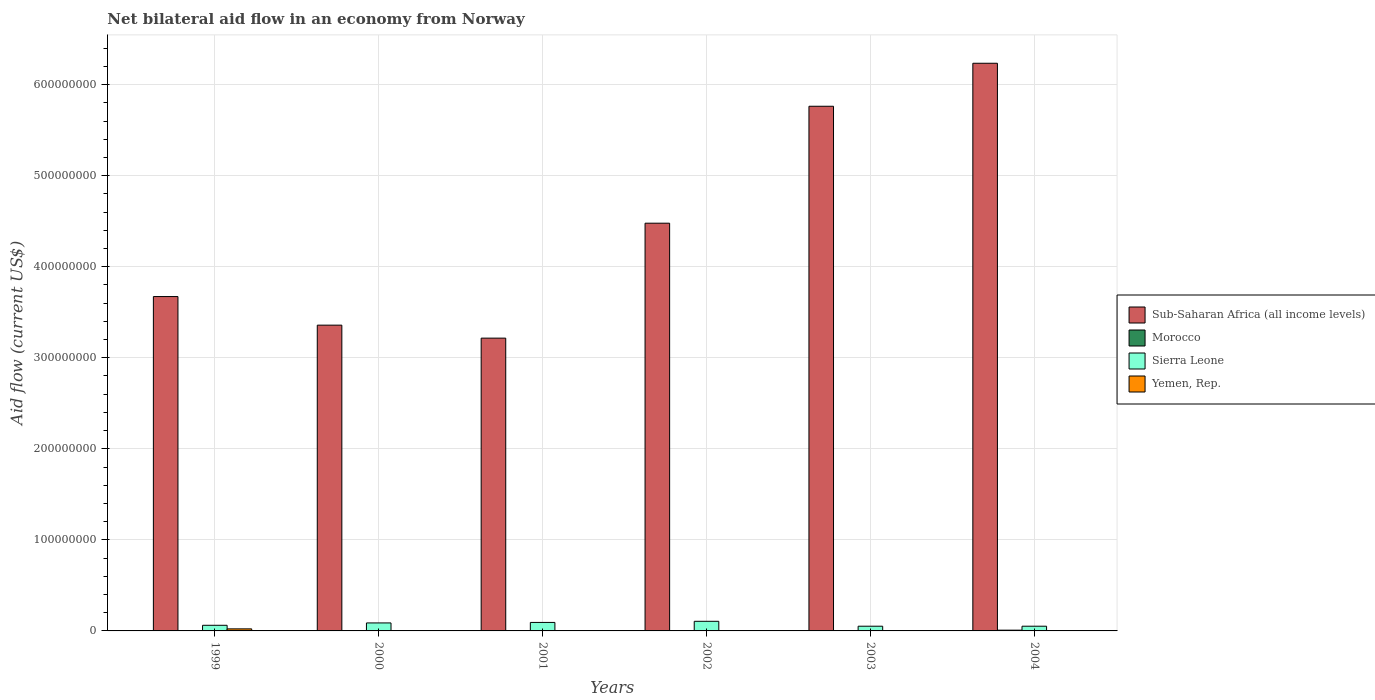How many different coloured bars are there?
Your response must be concise. 4. How many groups of bars are there?
Your answer should be very brief. 6. Are the number of bars on each tick of the X-axis equal?
Give a very brief answer. Yes. How many bars are there on the 1st tick from the left?
Provide a short and direct response. 4. How many bars are there on the 4th tick from the right?
Your answer should be compact. 4. What is the label of the 2nd group of bars from the left?
Provide a short and direct response. 2000. In how many cases, is the number of bars for a given year not equal to the number of legend labels?
Your answer should be very brief. 0. What is the net bilateral aid flow in Yemen, Rep. in 1999?
Ensure brevity in your answer.  2.25e+06. Across all years, what is the maximum net bilateral aid flow in Sub-Saharan Africa (all income levels)?
Provide a short and direct response. 6.23e+08. Across all years, what is the minimum net bilateral aid flow in Sierra Leone?
Make the answer very short. 5.17e+06. What is the total net bilateral aid flow in Sub-Saharan Africa (all income levels) in the graph?
Make the answer very short. 2.67e+09. What is the difference between the net bilateral aid flow in Sub-Saharan Africa (all income levels) in 1999 and that in 2002?
Your answer should be compact. -8.06e+07. What is the difference between the net bilateral aid flow in Morocco in 2001 and the net bilateral aid flow in Sierra Leone in 2004?
Make the answer very short. -5.08e+06. What is the average net bilateral aid flow in Sub-Saharan Africa (all income levels) per year?
Keep it short and to the point. 4.45e+08. In the year 2002, what is the difference between the net bilateral aid flow in Morocco and net bilateral aid flow in Sub-Saharan Africa (all income levels)?
Your answer should be compact. -4.48e+08. In how many years, is the net bilateral aid flow in Yemen, Rep. greater than 20000000 US$?
Offer a very short reply. 0. What is the ratio of the net bilateral aid flow in Morocco in 1999 to that in 2001?
Keep it short and to the point. 0.44. Is the net bilateral aid flow in Yemen, Rep. in 1999 less than that in 2000?
Offer a terse response. No. Is the difference between the net bilateral aid flow in Morocco in 2000 and 2002 greater than the difference between the net bilateral aid flow in Sub-Saharan Africa (all income levels) in 2000 and 2002?
Provide a succinct answer. Yes. What is the difference between the highest and the second highest net bilateral aid flow in Sierra Leone?
Offer a terse response. 1.24e+06. What is the difference between the highest and the lowest net bilateral aid flow in Yemen, Rep.?
Your answer should be very brief. 2.20e+06. Is the sum of the net bilateral aid flow in Yemen, Rep. in 2003 and 2004 greater than the maximum net bilateral aid flow in Sub-Saharan Africa (all income levels) across all years?
Provide a short and direct response. No. Is it the case that in every year, the sum of the net bilateral aid flow in Sierra Leone and net bilateral aid flow in Morocco is greater than the sum of net bilateral aid flow in Sub-Saharan Africa (all income levels) and net bilateral aid flow in Yemen, Rep.?
Your response must be concise. No. What does the 3rd bar from the left in 2001 represents?
Keep it short and to the point. Sierra Leone. What does the 1st bar from the right in 2004 represents?
Your answer should be very brief. Yemen, Rep. Are all the bars in the graph horizontal?
Offer a very short reply. No. How many years are there in the graph?
Provide a short and direct response. 6. Are the values on the major ticks of Y-axis written in scientific E-notation?
Make the answer very short. No. Does the graph contain any zero values?
Give a very brief answer. No. Does the graph contain grids?
Offer a terse response. Yes. What is the title of the graph?
Make the answer very short. Net bilateral aid flow in an economy from Norway. Does "Colombia" appear as one of the legend labels in the graph?
Keep it short and to the point. No. What is the label or title of the Y-axis?
Make the answer very short. Aid flow (current US$). What is the Aid flow (current US$) in Sub-Saharan Africa (all income levels) in 1999?
Your answer should be very brief. 3.67e+08. What is the Aid flow (current US$) of Sierra Leone in 1999?
Provide a short and direct response. 6.18e+06. What is the Aid flow (current US$) of Yemen, Rep. in 1999?
Your answer should be very brief. 2.25e+06. What is the Aid flow (current US$) in Sub-Saharan Africa (all income levels) in 2000?
Make the answer very short. 3.36e+08. What is the Aid flow (current US$) of Sierra Leone in 2000?
Make the answer very short. 8.77e+06. What is the Aid flow (current US$) in Sub-Saharan Africa (all income levels) in 2001?
Provide a short and direct response. 3.22e+08. What is the Aid flow (current US$) of Sierra Leone in 2001?
Provide a short and direct response. 9.33e+06. What is the Aid flow (current US$) of Sub-Saharan Africa (all income levels) in 2002?
Provide a succinct answer. 4.48e+08. What is the Aid flow (current US$) in Sierra Leone in 2002?
Your answer should be very brief. 1.06e+07. What is the Aid flow (current US$) of Yemen, Rep. in 2002?
Ensure brevity in your answer.  3.50e+05. What is the Aid flow (current US$) of Sub-Saharan Africa (all income levels) in 2003?
Your answer should be compact. 5.76e+08. What is the Aid flow (current US$) in Sierra Leone in 2003?
Offer a terse response. 5.18e+06. What is the Aid flow (current US$) of Yemen, Rep. in 2003?
Your answer should be very brief. 3.10e+05. What is the Aid flow (current US$) in Sub-Saharan Africa (all income levels) in 2004?
Give a very brief answer. 6.23e+08. What is the Aid flow (current US$) of Morocco in 2004?
Provide a succinct answer. 8.30e+05. What is the Aid flow (current US$) in Sierra Leone in 2004?
Provide a short and direct response. 5.17e+06. What is the Aid flow (current US$) in Yemen, Rep. in 2004?
Offer a very short reply. 4.30e+05. Across all years, what is the maximum Aid flow (current US$) in Sub-Saharan Africa (all income levels)?
Provide a short and direct response. 6.23e+08. Across all years, what is the maximum Aid flow (current US$) in Morocco?
Ensure brevity in your answer.  8.30e+05. Across all years, what is the maximum Aid flow (current US$) of Sierra Leone?
Your response must be concise. 1.06e+07. Across all years, what is the maximum Aid flow (current US$) of Yemen, Rep.?
Make the answer very short. 2.25e+06. Across all years, what is the minimum Aid flow (current US$) of Sub-Saharan Africa (all income levels)?
Provide a succinct answer. 3.22e+08. Across all years, what is the minimum Aid flow (current US$) of Morocco?
Your response must be concise. 4.00e+04. Across all years, what is the minimum Aid flow (current US$) in Sierra Leone?
Make the answer very short. 5.17e+06. Across all years, what is the minimum Aid flow (current US$) in Yemen, Rep.?
Provide a succinct answer. 5.00e+04. What is the total Aid flow (current US$) of Sub-Saharan Africa (all income levels) in the graph?
Offer a very short reply. 2.67e+09. What is the total Aid flow (current US$) in Morocco in the graph?
Give a very brief answer. 1.61e+06. What is the total Aid flow (current US$) in Sierra Leone in the graph?
Provide a short and direct response. 4.52e+07. What is the total Aid flow (current US$) of Yemen, Rep. in the graph?
Offer a terse response. 3.50e+06. What is the difference between the Aid flow (current US$) of Sub-Saharan Africa (all income levels) in 1999 and that in 2000?
Provide a short and direct response. 3.14e+07. What is the difference between the Aid flow (current US$) in Morocco in 1999 and that in 2000?
Provide a succinct answer. -8.00e+04. What is the difference between the Aid flow (current US$) in Sierra Leone in 1999 and that in 2000?
Make the answer very short. -2.59e+06. What is the difference between the Aid flow (current US$) of Yemen, Rep. in 1999 and that in 2000?
Your answer should be very brief. 2.14e+06. What is the difference between the Aid flow (current US$) of Sub-Saharan Africa (all income levels) in 1999 and that in 2001?
Provide a short and direct response. 4.57e+07. What is the difference between the Aid flow (current US$) in Morocco in 1999 and that in 2001?
Provide a short and direct response. -5.00e+04. What is the difference between the Aid flow (current US$) in Sierra Leone in 1999 and that in 2001?
Offer a terse response. -3.15e+06. What is the difference between the Aid flow (current US$) of Yemen, Rep. in 1999 and that in 2001?
Offer a terse response. 2.20e+06. What is the difference between the Aid flow (current US$) in Sub-Saharan Africa (all income levels) in 1999 and that in 2002?
Your answer should be very brief. -8.06e+07. What is the difference between the Aid flow (current US$) of Morocco in 1999 and that in 2002?
Your response must be concise. -1.30e+05. What is the difference between the Aid flow (current US$) in Sierra Leone in 1999 and that in 2002?
Ensure brevity in your answer.  -4.39e+06. What is the difference between the Aid flow (current US$) in Yemen, Rep. in 1999 and that in 2002?
Ensure brevity in your answer.  1.90e+06. What is the difference between the Aid flow (current US$) of Sub-Saharan Africa (all income levels) in 1999 and that in 2003?
Offer a terse response. -2.09e+08. What is the difference between the Aid flow (current US$) in Morocco in 1999 and that in 2003?
Your response must be concise. -3.20e+05. What is the difference between the Aid flow (current US$) in Sierra Leone in 1999 and that in 2003?
Offer a very short reply. 1.00e+06. What is the difference between the Aid flow (current US$) in Yemen, Rep. in 1999 and that in 2003?
Provide a succinct answer. 1.94e+06. What is the difference between the Aid flow (current US$) in Sub-Saharan Africa (all income levels) in 1999 and that in 2004?
Make the answer very short. -2.56e+08. What is the difference between the Aid flow (current US$) of Morocco in 1999 and that in 2004?
Keep it short and to the point. -7.90e+05. What is the difference between the Aid flow (current US$) in Sierra Leone in 1999 and that in 2004?
Provide a succinct answer. 1.01e+06. What is the difference between the Aid flow (current US$) in Yemen, Rep. in 1999 and that in 2004?
Provide a succinct answer. 1.82e+06. What is the difference between the Aid flow (current US$) of Sub-Saharan Africa (all income levels) in 2000 and that in 2001?
Ensure brevity in your answer.  1.43e+07. What is the difference between the Aid flow (current US$) of Sierra Leone in 2000 and that in 2001?
Offer a terse response. -5.60e+05. What is the difference between the Aid flow (current US$) of Sub-Saharan Africa (all income levels) in 2000 and that in 2002?
Offer a very short reply. -1.12e+08. What is the difference between the Aid flow (current US$) of Morocco in 2000 and that in 2002?
Offer a very short reply. -5.00e+04. What is the difference between the Aid flow (current US$) of Sierra Leone in 2000 and that in 2002?
Make the answer very short. -1.80e+06. What is the difference between the Aid flow (current US$) in Yemen, Rep. in 2000 and that in 2002?
Provide a succinct answer. -2.40e+05. What is the difference between the Aid flow (current US$) in Sub-Saharan Africa (all income levels) in 2000 and that in 2003?
Your response must be concise. -2.40e+08. What is the difference between the Aid flow (current US$) in Sierra Leone in 2000 and that in 2003?
Make the answer very short. 3.59e+06. What is the difference between the Aid flow (current US$) of Yemen, Rep. in 2000 and that in 2003?
Offer a very short reply. -2.00e+05. What is the difference between the Aid flow (current US$) of Sub-Saharan Africa (all income levels) in 2000 and that in 2004?
Offer a terse response. -2.88e+08. What is the difference between the Aid flow (current US$) of Morocco in 2000 and that in 2004?
Ensure brevity in your answer.  -7.10e+05. What is the difference between the Aid flow (current US$) in Sierra Leone in 2000 and that in 2004?
Offer a terse response. 3.60e+06. What is the difference between the Aid flow (current US$) of Yemen, Rep. in 2000 and that in 2004?
Your response must be concise. -3.20e+05. What is the difference between the Aid flow (current US$) in Sub-Saharan Africa (all income levels) in 2001 and that in 2002?
Your response must be concise. -1.26e+08. What is the difference between the Aid flow (current US$) of Morocco in 2001 and that in 2002?
Your answer should be very brief. -8.00e+04. What is the difference between the Aid flow (current US$) of Sierra Leone in 2001 and that in 2002?
Ensure brevity in your answer.  -1.24e+06. What is the difference between the Aid flow (current US$) in Yemen, Rep. in 2001 and that in 2002?
Your answer should be very brief. -3.00e+05. What is the difference between the Aid flow (current US$) of Sub-Saharan Africa (all income levels) in 2001 and that in 2003?
Provide a short and direct response. -2.55e+08. What is the difference between the Aid flow (current US$) in Morocco in 2001 and that in 2003?
Offer a terse response. -2.70e+05. What is the difference between the Aid flow (current US$) of Sierra Leone in 2001 and that in 2003?
Offer a very short reply. 4.15e+06. What is the difference between the Aid flow (current US$) in Sub-Saharan Africa (all income levels) in 2001 and that in 2004?
Keep it short and to the point. -3.02e+08. What is the difference between the Aid flow (current US$) of Morocco in 2001 and that in 2004?
Give a very brief answer. -7.40e+05. What is the difference between the Aid flow (current US$) of Sierra Leone in 2001 and that in 2004?
Your answer should be very brief. 4.16e+06. What is the difference between the Aid flow (current US$) of Yemen, Rep. in 2001 and that in 2004?
Make the answer very short. -3.80e+05. What is the difference between the Aid flow (current US$) in Sub-Saharan Africa (all income levels) in 2002 and that in 2003?
Your answer should be very brief. -1.28e+08. What is the difference between the Aid flow (current US$) in Morocco in 2002 and that in 2003?
Offer a terse response. -1.90e+05. What is the difference between the Aid flow (current US$) of Sierra Leone in 2002 and that in 2003?
Give a very brief answer. 5.39e+06. What is the difference between the Aid flow (current US$) of Yemen, Rep. in 2002 and that in 2003?
Provide a succinct answer. 4.00e+04. What is the difference between the Aid flow (current US$) of Sub-Saharan Africa (all income levels) in 2002 and that in 2004?
Keep it short and to the point. -1.76e+08. What is the difference between the Aid flow (current US$) in Morocco in 2002 and that in 2004?
Offer a terse response. -6.60e+05. What is the difference between the Aid flow (current US$) of Sierra Leone in 2002 and that in 2004?
Give a very brief answer. 5.40e+06. What is the difference between the Aid flow (current US$) in Yemen, Rep. in 2002 and that in 2004?
Offer a very short reply. -8.00e+04. What is the difference between the Aid flow (current US$) in Sub-Saharan Africa (all income levels) in 2003 and that in 2004?
Provide a succinct answer. -4.72e+07. What is the difference between the Aid flow (current US$) in Morocco in 2003 and that in 2004?
Provide a short and direct response. -4.70e+05. What is the difference between the Aid flow (current US$) of Yemen, Rep. in 2003 and that in 2004?
Offer a very short reply. -1.20e+05. What is the difference between the Aid flow (current US$) in Sub-Saharan Africa (all income levels) in 1999 and the Aid flow (current US$) in Morocco in 2000?
Offer a terse response. 3.67e+08. What is the difference between the Aid flow (current US$) in Sub-Saharan Africa (all income levels) in 1999 and the Aid flow (current US$) in Sierra Leone in 2000?
Provide a short and direct response. 3.58e+08. What is the difference between the Aid flow (current US$) in Sub-Saharan Africa (all income levels) in 1999 and the Aid flow (current US$) in Yemen, Rep. in 2000?
Provide a short and direct response. 3.67e+08. What is the difference between the Aid flow (current US$) in Morocco in 1999 and the Aid flow (current US$) in Sierra Leone in 2000?
Make the answer very short. -8.73e+06. What is the difference between the Aid flow (current US$) in Morocco in 1999 and the Aid flow (current US$) in Yemen, Rep. in 2000?
Offer a terse response. -7.00e+04. What is the difference between the Aid flow (current US$) of Sierra Leone in 1999 and the Aid flow (current US$) of Yemen, Rep. in 2000?
Make the answer very short. 6.07e+06. What is the difference between the Aid flow (current US$) in Sub-Saharan Africa (all income levels) in 1999 and the Aid flow (current US$) in Morocco in 2001?
Make the answer very short. 3.67e+08. What is the difference between the Aid flow (current US$) in Sub-Saharan Africa (all income levels) in 1999 and the Aid flow (current US$) in Sierra Leone in 2001?
Give a very brief answer. 3.58e+08. What is the difference between the Aid flow (current US$) in Sub-Saharan Africa (all income levels) in 1999 and the Aid flow (current US$) in Yemen, Rep. in 2001?
Provide a short and direct response. 3.67e+08. What is the difference between the Aid flow (current US$) of Morocco in 1999 and the Aid flow (current US$) of Sierra Leone in 2001?
Ensure brevity in your answer.  -9.29e+06. What is the difference between the Aid flow (current US$) of Morocco in 1999 and the Aid flow (current US$) of Yemen, Rep. in 2001?
Keep it short and to the point. -10000. What is the difference between the Aid flow (current US$) of Sierra Leone in 1999 and the Aid flow (current US$) of Yemen, Rep. in 2001?
Your answer should be very brief. 6.13e+06. What is the difference between the Aid flow (current US$) of Sub-Saharan Africa (all income levels) in 1999 and the Aid flow (current US$) of Morocco in 2002?
Provide a short and direct response. 3.67e+08. What is the difference between the Aid flow (current US$) of Sub-Saharan Africa (all income levels) in 1999 and the Aid flow (current US$) of Sierra Leone in 2002?
Keep it short and to the point. 3.57e+08. What is the difference between the Aid flow (current US$) of Sub-Saharan Africa (all income levels) in 1999 and the Aid flow (current US$) of Yemen, Rep. in 2002?
Keep it short and to the point. 3.67e+08. What is the difference between the Aid flow (current US$) of Morocco in 1999 and the Aid flow (current US$) of Sierra Leone in 2002?
Make the answer very short. -1.05e+07. What is the difference between the Aid flow (current US$) in Morocco in 1999 and the Aid flow (current US$) in Yemen, Rep. in 2002?
Your answer should be very brief. -3.10e+05. What is the difference between the Aid flow (current US$) of Sierra Leone in 1999 and the Aid flow (current US$) of Yemen, Rep. in 2002?
Your answer should be very brief. 5.83e+06. What is the difference between the Aid flow (current US$) in Sub-Saharan Africa (all income levels) in 1999 and the Aid flow (current US$) in Morocco in 2003?
Ensure brevity in your answer.  3.67e+08. What is the difference between the Aid flow (current US$) in Sub-Saharan Africa (all income levels) in 1999 and the Aid flow (current US$) in Sierra Leone in 2003?
Your answer should be very brief. 3.62e+08. What is the difference between the Aid flow (current US$) of Sub-Saharan Africa (all income levels) in 1999 and the Aid flow (current US$) of Yemen, Rep. in 2003?
Your answer should be very brief. 3.67e+08. What is the difference between the Aid flow (current US$) in Morocco in 1999 and the Aid flow (current US$) in Sierra Leone in 2003?
Your response must be concise. -5.14e+06. What is the difference between the Aid flow (current US$) in Sierra Leone in 1999 and the Aid flow (current US$) in Yemen, Rep. in 2003?
Provide a short and direct response. 5.87e+06. What is the difference between the Aid flow (current US$) in Sub-Saharan Africa (all income levels) in 1999 and the Aid flow (current US$) in Morocco in 2004?
Your response must be concise. 3.66e+08. What is the difference between the Aid flow (current US$) in Sub-Saharan Africa (all income levels) in 1999 and the Aid flow (current US$) in Sierra Leone in 2004?
Your answer should be compact. 3.62e+08. What is the difference between the Aid flow (current US$) of Sub-Saharan Africa (all income levels) in 1999 and the Aid flow (current US$) of Yemen, Rep. in 2004?
Ensure brevity in your answer.  3.67e+08. What is the difference between the Aid flow (current US$) of Morocco in 1999 and the Aid flow (current US$) of Sierra Leone in 2004?
Offer a terse response. -5.13e+06. What is the difference between the Aid flow (current US$) of Morocco in 1999 and the Aid flow (current US$) of Yemen, Rep. in 2004?
Provide a succinct answer. -3.90e+05. What is the difference between the Aid flow (current US$) in Sierra Leone in 1999 and the Aid flow (current US$) in Yemen, Rep. in 2004?
Provide a succinct answer. 5.75e+06. What is the difference between the Aid flow (current US$) in Sub-Saharan Africa (all income levels) in 2000 and the Aid flow (current US$) in Morocco in 2001?
Your response must be concise. 3.36e+08. What is the difference between the Aid flow (current US$) of Sub-Saharan Africa (all income levels) in 2000 and the Aid flow (current US$) of Sierra Leone in 2001?
Provide a succinct answer. 3.27e+08. What is the difference between the Aid flow (current US$) in Sub-Saharan Africa (all income levels) in 2000 and the Aid flow (current US$) in Yemen, Rep. in 2001?
Your answer should be compact. 3.36e+08. What is the difference between the Aid flow (current US$) of Morocco in 2000 and the Aid flow (current US$) of Sierra Leone in 2001?
Offer a terse response. -9.21e+06. What is the difference between the Aid flow (current US$) of Sierra Leone in 2000 and the Aid flow (current US$) of Yemen, Rep. in 2001?
Provide a succinct answer. 8.72e+06. What is the difference between the Aid flow (current US$) of Sub-Saharan Africa (all income levels) in 2000 and the Aid flow (current US$) of Morocco in 2002?
Provide a short and direct response. 3.36e+08. What is the difference between the Aid flow (current US$) in Sub-Saharan Africa (all income levels) in 2000 and the Aid flow (current US$) in Sierra Leone in 2002?
Ensure brevity in your answer.  3.25e+08. What is the difference between the Aid flow (current US$) of Sub-Saharan Africa (all income levels) in 2000 and the Aid flow (current US$) of Yemen, Rep. in 2002?
Provide a short and direct response. 3.35e+08. What is the difference between the Aid flow (current US$) of Morocco in 2000 and the Aid flow (current US$) of Sierra Leone in 2002?
Offer a very short reply. -1.04e+07. What is the difference between the Aid flow (current US$) of Sierra Leone in 2000 and the Aid flow (current US$) of Yemen, Rep. in 2002?
Make the answer very short. 8.42e+06. What is the difference between the Aid flow (current US$) in Sub-Saharan Africa (all income levels) in 2000 and the Aid flow (current US$) in Morocco in 2003?
Offer a very short reply. 3.35e+08. What is the difference between the Aid flow (current US$) of Sub-Saharan Africa (all income levels) in 2000 and the Aid flow (current US$) of Sierra Leone in 2003?
Ensure brevity in your answer.  3.31e+08. What is the difference between the Aid flow (current US$) in Sub-Saharan Africa (all income levels) in 2000 and the Aid flow (current US$) in Yemen, Rep. in 2003?
Ensure brevity in your answer.  3.36e+08. What is the difference between the Aid flow (current US$) of Morocco in 2000 and the Aid flow (current US$) of Sierra Leone in 2003?
Give a very brief answer. -5.06e+06. What is the difference between the Aid flow (current US$) of Morocco in 2000 and the Aid flow (current US$) of Yemen, Rep. in 2003?
Offer a very short reply. -1.90e+05. What is the difference between the Aid flow (current US$) of Sierra Leone in 2000 and the Aid flow (current US$) of Yemen, Rep. in 2003?
Keep it short and to the point. 8.46e+06. What is the difference between the Aid flow (current US$) of Sub-Saharan Africa (all income levels) in 2000 and the Aid flow (current US$) of Morocco in 2004?
Make the answer very short. 3.35e+08. What is the difference between the Aid flow (current US$) in Sub-Saharan Africa (all income levels) in 2000 and the Aid flow (current US$) in Sierra Leone in 2004?
Provide a succinct answer. 3.31e+08. What is the difference between the Aid flow (current US$) in Sub-Saharan Africa (all income levels) in 2000 and the Aid flow (current US$) in Yemen, Rep. in 2004?
Keep it short and to the point. 3.35e+08. What is the difference between the Aid flow (current US$) in Morocco in 2000 and the Aid flow (current US$) in Sierra Leone in 2004?
Your answer should be compact. -5.05e+06. What is the difference between the Aid flow (current US$) in Morocco in 2000 and the Aid flow (current US$) in Yemen, Rep. in 2004?
Your answer should be compact. -3.10e+05. What is the difference between the Aid flow (current US$) in Sierra Leone in 2000 and the Aid flow (current US$) in Yemen, Rep. in 2004?
Ensure brevity in your answer.  8.34e+06. What is the difference between the Aid flow (current US$) in Sub-Saharan Africa (all income levels) in 2001 and the Aid flow (current US$) in Morocco in 2002?
Your answer should be compact. 3.21e+08. What is the difference between the Aid flow (current US$) in Sub-Saharan Africa (all income levels) in 2001 and the Aid flow (current US$) in Sierra Leone in 2002?
Your response must be concise. 3.11e+08. What is the difference between the Aid flow (current US$) of Sub-Saharan Africa (all income levels) in 2001 and the Aid flow (current US$) of Yemen, Rep. in 2002?
Offer a terse response. 3.21e+08. What is the difference between the Aid flow (current US$) of Morocco in 2001 and the Aid flow (current US$) of Sierra Leone in 2002?
Your response must be concise. -1.05e+07. What is the difference between the Aid flow (current US$) of Morocco in 2001 and the Aid flow (current US$) of Yemen, Rep. in 2002?
Your answer should be very brief. -2.60e+05. What is the difference between the Aid flow (current US$) in Sierra Leone in 2001 and the Aid flow (current US$) in Yemen, Rep. in 2002?
Provide a short and direct response. 8.98e+06. What is the difference between the Aid flow (current US$) of Sub-Saharan Africa (all income levels) in 2001 and the Aid flow (current US$) of Morocco in 2003?
Give a very brief answer. 3.21e+08. What is the difference between the Aid flow (current US$) of Sub-Saharan Africa (all income levels) in 2001 and the Aid flow (current US$) of Sierra Leone in 2003?
Offer a very short reply. 3.16e+08. What is the difference between the Aid flow (current US$) of Sub-Saharan Africa (all income levels) in 2001 and the Aid flow (current US$) of Yemen, Rep. in 2003?
Give a very brief answer. 3.21e+08. What is the difference between the Aid flow (current US$) in Morocco in 2001 and the Aid flow (current US$) in Sierra Leone in 2003?
Your response must be concise. -5.09e+06. What is the difference between the Aid flow (current US$) in Morocco in 2001 and the Aid flow (current US$) in Yemen, Rep. in 2003?
Offer a terse response. -2.20e+05. What is the difference between the Aid flow (current US$) in Sierra Leone in 2001 and the Aid flow (current US$) in Yemen, Rep. in 2003?
Keep it short and to the point. 9.02e+06. What is the difference between the Aid flow (current US$) in Sub-Saharan Africa (all income levels) in 2001 and the Aid flow (current US$) in Morocco in 2004?
Your answer should be very brief. 3.21e+08. What is the difference between the Aid flow (current US$) in Sub-Saharan Africa (all income levels) in 2001 and the Aid flow (current US$) in Sierra Leone in 2004?
Your answer should be very brief. 3.16e+08. What is the difference between the Aid flow (current US$) of Sub-Saharan Africa (all income levels) in 2001 and the Aid flow (current US$) of Yemen, Rep. in 2004?
Your response must be concise. 3.21e+08. What is the difference between the Aid flow (current US$) of Morocco in 2001 and the Aid flow (current US$) of Sierra Leone in 2004?
Provide a succinct answer. -5.08e+06. What is the difference between the Aid flow (current US$) in Sierra Leone in 2001 and the Aid flow (current US$) in Yemen, Rep. in 2004?
Give a very brief answer. 8.90e+06. What is the difference between the Aid flow (current US$) in Sub-Saharan Africa (all income levels) in 2002 and the Aid flow (current US$) in Morocco in 2003?
Offer a very short reply. 4.47e+08. What is the difference between the Aid flow (current US$) of Sub-Saharan Africa (all income levels) in 2002 and the Aid flow (current US$) of Sierra Leone in 2003?
Offer a terse response. 4.43e+08. What is the difference between the Aid flow (current US$) in Sub-Saharan Africa (all income levels) in 2002 and the Aid flow (current US$) in Yemen, Rep. in 2003?
Your answer should be compact. 4.48e+08. What is the difference between the Aid flow (current US$) in Morocco in 2002 and the Aid flow (current US$) in Sierra Leone in 2003?
Offer a terse response. -5.01e+06. What is the difference between the Aid flow (current US$) of Sierra Leone in 2002 and the Aid flow (current US$) of Yemen, Rep. in 2003?
Give a very brief answer. 1.03e+07. What is the difference between the Aid flow (current US$) of Sub-Saharan Africa (all income levels) in 2002 and the Aid flow (current US$) of Morocco in 2004?
Provide a succinct answer. 4.47e+08. What is the difference between the Aid flow (current US$) of Sub-Saharan Africa (all income levels) in 2002 and the Aid flow (current US$) of Sierra Leone in 2004?
Your response must be concise. 4.43e+08. What is the difference between the Aid flow (current US$) of Sub-Saharan Africa (all income levels) in 2002 and the Aid flow (current US$) of Yemen, Rep. in 2004?
Offer a very short reply. 4.47e+08. What is the difference between the Aid flow (current US$) of Morocco in 2002 and the Aid flow (current US$) of Sierra Leone in 2004?
Keep it short and to the point. -5.00e+06. What is the difference between the Aid flow (current US$) in Sierra Leone in 2002 and the Aid flow (current US$) in Yemen, Rep. in 2004?
Offer a very short reply. 1.01e+07. What is the difference between the Aid flow (current US$) of Sub-Saharan Africa (all income levels) in 2003 and the Aid flow (current US$) of Morocco in 2004?
Offer a terse response. 5.75e+08. What is the difference between the Aid flow (current US$) of Sub-Saharan Africa (all income levels) in 2003 and the Aid flow (current US$) of Sierra Leone in 2004?
Provide a short and direct response. 5.71e+08. What is the difference between the Aid flow (current US$) in Sub-Saharan Africa (all income levels) in 2003 and the Aid flow (current US$) in Yemen, Rep. in 2004?
Provide a succinct answer. 5.76e+08. What is the difference between the Aid flow (current US$) in Morocco in 2003 and the Aid flow (current US$) in Sierra Leone in 2004?
Make the answer very short. -4.81e+06. What is the difference between the Aid flow (current US$) of Morocco in 2003 and the Aid flow (current US$) of Yemen, Rep. in 2004?
Offer a terse response. -7.00e+04. What is the difference between the Aid flow (current US$) in Sierra Leone in 2003 and the Aid flow (current US$) in Yemen, Rep. in 2004?
Your response must be concise. 4.75e+06. What is the average Aid flow (current US$) in Sub-Saharan Africa (all income levels) per year?
Provide a succinct answer. 4.45e+08. What is the average Aid flow (current US$) in Morocco per year?
Make the answer very short. 2.68e+05. What is the average Aid flow (current US$) of Sierra Leone per year?
Ensure brevity in your answer.  7.53e+06. What is the average Aid flow (current US$) in Yemen, Rep. per year?
Provide a short and direct response. 5.83e+05. In the year 1999, what is the difference between the Aid flow (current US$) of Sub-Saharan Africa (all income levels) and Aid flow (current US$) of Morocco?
Offer a terse response. 3.67e+08. In the year 1999, what is the difference between the Aid flow (current US$) in Sub-Saharan Africa (all income levels) and Aid flow (current US$) in Sierra Leone?
Give a very brief answer. 3.61e+08. In the year 1999, what is the difference between the Aid flow (current US$) of Sub-Saharan Africa (all income levels) and Aid flow (current US$) of Yemen, Rep.?
Ensure brevity in your answer.  3.65e+08. In the year 1999, what is the difference between the Aid flow (current US$) in Morocco and Aid flow (current US$) in Sierra Leone?
Offer a terse response. -6.14e+06. In the year 1999, what is the difference between the Aid flow (current US$) in Morocco and Aid flow (current US$) in Yemen, Rep.?
Provide a short and direct response. -2.21e+06. In the year 1999, what is the difference between the Aid flow (current US$) of Sierra Leone and Aid flow (current US$) of Yemen, Rep.?
Your response must be concise. 3.93e+06. In the year 2000, what is the difference between the Aid flow (current US$) in Sub-Saharan Africa (all income levels) and Aid flow (current US$) in Morocco?
Keep it short and to the point. 3.36e+08. In the year 2000, what is the difference between the Aid flow (current US$) of Sub-Saharan Africa (all income levels) and Aid flow (current US$) of Sierra Leone?
Provide a short and direct response. 3.27e+08. In the year 2000, what is the difference between the Aid flow (current US$) in Sub-Saharan Africa (all income levels) and Aid flow (current US$) in Yemen, Rep.?
Offer a terse response. 3.36e+08. In the year 2000, what is the difference between the Aid flow (current US$) of Morocco and Aid flow (current US$) of Sierra Leone?
Provide a succinct answer. -8.65e+06. In the year 2000, what is the difference between the Aid flow (current US$) of Sierra Leone and Aid flow (current US$) of Yemen, Rep.?
Keep it short and to the point. 8.66e+06. In the year 2001, what is the difference between the Aid flow (current US$) of Sub-Saharan Africa (all income levels) and Aid flow (current US$) of Morocco?
Keep it short and to the point. 3.21e+08. In the year 2001, what is the difference between the Aid flow (current US$) in Sub-Saharan Africa (all income levels) and Aid flow (current US$) in Sierra Leone?
Give a very brief answer. 3.12e+08. In the year 2001, what is the difference between the Aid flow (current US$) of Sub-Saharan Africa (all income levels) and Aid flow (current US$) of Yemen, Rep.?
Provide a short and direct response. 3.22e+08. In the year 2001, what is the difference between the Aid flow (current US$) of Morocco and Aid flow (current US$) of Sierra Leone?
Offer a terse response. -9.24e+06. In the year 2001, what is the difference between the Aid flow (current US$) of Sierra Leone and Aid flow (current US$) of Yemen, Rep.?
Your answer should be compact. 9.28e+06. In the year 2002, what is the difference between the Aid flow (current US$) of Sub-Saharan Africa (all income levels) and Aid flow (current US$) of Morocco?
Offer a very short reply. 4.48e+08. In the year 2002, what is the difference between the Aid flow (current US$) in Sub-Saharan Africa (all income levels) and Aid flow (current US$) in Sierra Leone?
Your answer should be compact. 4.37e+08. In the year 2002, what is the difference between the Aid flow (current US$) in Sub-Saharan Africa (all income levels) and Aid flow (current US$) in Yemen, Rep.?
Provide a short and direct response. 4.47e+08. In the year 2002, what is the difference between the Aid flow (current US$) of Morocco and Aid flow (current US$) of Sierra Leone?
Your answer should be compact. -1.04e+07. In the year 2002, what is the difference between the Aid flow (current US$) in Sierra Leone and Aid flow (current US$) in Yemen, Rep.?
Your response must be concise. 1.02e+07. In the year 2003, what is the difference between the Aid flow (current US$) of Sub-Saharan Africa (all income levels) and Aid flow (current US$) of Morocco?
Make the answer very short. 5.76e+08. In the year 2003, what is the difference between the Aid flow (current US$) in Sub-Saharan Africa (all income levels) and Aid flow (current US$) in Sierra Leone?
Give a very brief answer. 5.71e+08. In the year 2003, what is the difference between the Aid flow (current US$) of Sub-Saharan Africa (all income levels) and Aid flow (current US$) of Yemen, Rep.?
Provide a succinct answer. 5.76e+08. In the year 2003, what is the difference between the Aid flow (current US$) in Morocco and Aid flow (current US$) in Sierra Leone?
Make the answer very short. -4.82e+06. In the year 2003, what is the difference between the Aid flow (current US$) of Sierra Leone and Aid flow (current US$) of Yemen, Rep.?
Offer a terse response. 4.87e+06. In the year 2004, what is the difference between the Aid flow (current US$) of Sub-Saharan Africa (all income levels) and Aid flow (current US$) of Morocco?
Ensure brevity in your answer.  6.23e+08. In the year 2004, what is the difference between the Aid flow (current US$) of Sub-Saharan Africa (all income levels) and Aid flow (current US$) of Sierra Leone?
Your response must be concise. 6.18e+08. In the year 2004, what is the difference between the Aid flow (current US$) of Sub-Saharan Africa (all income levels) and Aid flow (current US$) of Yemen, Rep.?
Your answer should be compact. 6.23e+08. In the year 2004, what is the difference between the Aid flow (current US$) in Morocco and Aid flow (current US$) in Sierra Leone?
Offer a very short reply. -4.34e+06. In the year 2004, what is the difference between the Aid flow (current US$) of Sierra Leone and Aid flow (current US$) of Yemen, Rep.?
Provide a short and direct response. 4.74e+06. What is the ratio of the Aid flow (current US$) in Sub-Saharan Africa (all income levels) in 1999 to that in 2000?
Keep it short and to the point. 1.09. What is the ratio of the Aid flow (current US$) in Morocco in 1999 to that in 2000?
Ensure brevity in your answer.  0.33. What is the ratio of the Aid flow (current US$) of Sierra Leone in 1999 to that in 2000?
Your response must be concise. 0.7. What is the ratio of the Aid flow (current US$) of Yemen, Rep. in 1999 to that in 2000?
Your answer should be very brief. 20.45. What is the ratio of the Aid flow (current US$) of Sub-Saharan Africa (all income levels) in 1999 to that in 2001?
Offer a terse response. 1.14. What is the ratio of the Aid flow (current US$) in Morocco in 1999 to that in 2001?
Offer a very short reply. 0.44. What is the ratio of the Aid flow (current US$) of Sierra Leone in 1999 to that in 2001?
Your answer should be compact. 0.66. What is the ratio of the Aid flow (current US$) of Yemen, Rep. in 1999 to that in 2001?
Ensure brevity in your answer.  45. What is the ratio of the Aid flow (current US$) of Sub-Saharan Africa (all income levels) in 1999 to that in 2002?
Provide a succinct answer. 0.82. What is the ratio of the Aid flow (current US$) in Morocco in 1999 to that in 2002?
Give a very brief answer. 0.24. What is the ratio of the Aid flow (current US$) in Sierra Leone in 1999 to that in 2002?
Your answer should be compact. 0.58. What is the ratio of the Aid flow (current US$) in Yemen, Rep. in 1999 to that in 2002?
Offer a terse response. 6.43. What is the ratio of the Aid flow (current US$) in Sub-Saharan Africa (all income levels) in 1999 to that in 2003?
Your answer should be very brief. 0.64. What is the ratio of the Aid flow (current US$) in Sierra Leone in 1999 to that in 2003?
Ensure brevity in your answer.  1.19. What is the ratio of the Aid flow (current US$) of Yemen, Rep. in 1999 to that in 2003?
Your answer should be very brief. 7.26. What is the ratio of the Aid flow (current US$) in Sub-Saharan Africa (all income levels) in 1999 to that in 2004?
Your answer should be very brief. 0.59. What is the ratio of the Aid flow (current US$) of Morocco in 1999 to that in 2004?
Provide a short and direct response. 0.05. What is the ratio of the Aid flow (current US$) of Sierra Leone in 1999 to that in 2004?
Offer a very short reply. 1.2. What is the ratio of the Aid flow (current US$) in Yemen, Rep. in 1999 to that in 2004?
Your answer should be compact. 5.23. What is the ratio of the Aid flow (current US$) in Sub-Saharan Africa (all income levels) in 2000 to that in 2001?
Offer a terse response. 1.04. What is the ratio of the Aid flow (current US$) of Morocco in 2000 to that in 2001?
Your answer should be very brief. 1.33. What is the ratio of the Aid flow (current US$) in Sierra Leone in 2000 to that in 2001?
Your answer should be very brief. 0.94. What is the ratio of the Aid flow (current US$) in Sub-Saharan Africa (all income levels) in 2000 to that in 2002?
Make the answer very short. 0.75. What is the ratio of the Aid flow (current US$) of Morocco in 2000 to that in 2002?
Your answer should be compact. 0.71. What is the ratio of the Aid flow (current US$) in Sierra Leone in 2000 to that in 2002?
Your answer should be very brief. 0.83. What is the ratio of the Aid flow (current US$) in Yemen, Rep. in 2000 to that in 2002?
Keep it short and to the point. 0.31. What is the ratio of the Aid flow (current US$) of Sub-Saharan Africa (all income levels) in 2000 to that in 2003?
Give a very brief answer. 0.58. What is the ratio of the Aid flow (current US$) of Morocco in 2000 to that in 2003?
Provide a succinct answer. 0.33. What is the ratio of the Aid flow (current US$) of Sierra Leone in 2000 to that in 2003?
Ensure brevity in your answer.  1.69. What is the ratio of the Aid flow (current US$) in Yemen, Rep. in 2000 to that in 2003?
Offer a terse response. 0.35. What is the ratio of the Aid flow (current US$) in Sub-Saharan Africa (all income levels) in 2000 to that in 2004?
Ensure brevity in your answer.  0.54. What is the ratio of the Aid flow (current US$) of Morocco in 2000 to that in 2004?
Ensure brevity in your answer.  0.14. What is the ratio of the Aid flow (current US$) in Sierra Leone in 2000 to that in 2004?
Keep it short and to the point. 1.7. What is the ratio of the Aid flow (current US$) of Yemen, Rep. in 2000 to that in 2004?
Make the answer very short. 0.26. What is the ratio of the Aid flow (current US$) of Sub-Saharan Africa (all income levels) in 2001 to that in 2002?
Your answer should be compact. 0.72. What is the ratio of the Aid flow (current US$) in Morocco in 2001 to that in 2002?
Offer a very short reply. 0.53. What is the ratio of the Aid flow (current US$) in Sierra Leone in 2001 to that in 2002?
Your answer should be compact. 0.88. What is the ratio of the Aid flow (current US$) in Yemen, Rep. in 2001 to that in 2002?
Your answer should be compact. 0.14. What is the ratio of the Aid flow (current US$) in Sub-Saharan Africa (all income levels) in 2001 to that in 2003?
Your answer should be compact. 0.56. What is the ratio of the Aid flow (current US$) in Morocco in 2001 to that in 2003?
Offer a terse response. 0.25. What is the ratio of the Aid flow (current US$) of Sierra Leone in 2001 to that in 2003?
Give a very brief answer. 1.8. What is the ratio of the Aid flow (current US$) in Yemen, Rep. in 2001 to that in 2003?
Your answer should be compact. 0.16. What is the ratio of the Aid flow (current US$) of Sub-Saharan Africa (all income levels) in 2001 to that in 2004?
Ensure brevity in your answer.  0.52. What is the ratio of the Aid flow (current US$) in Morocco in 2001 to that in 2004?
Keep it short and to the point. 0.11. What is the ratio of the Aid flow (current US$) in Sierra Leone in 2001 to that in 2004?
Provide a succinct answer. 1.8. What is the ratio of the Aid flow (current US$) of Yemen, Rep. in 2001 to that in 2004?
Give a very brief answer. 0.12. What is the ratio of the Aid flow (current US$) in Sub-Saharan Africa (all income levels) in 2002 to that in 2003?
Your answer should be very brief. 0.78. What is the ratio of the Aid flow (current US$) in Morocco in 2002 to that in 2003?
Your answer should be compact. 0.47. What is the ratio of the Aid flow (current US$) in Sierra Leone in 2002 to that in 2003?
Offer a terse response. 2.04. What is the ratio of the Aid flow (current US$) in Yemen, Rep. in 2002 to that in 2003?
Your answer should be compact. 1.13. What is the ratio of the Aid flow (current US$) of Sub-Saharan Africa (all income levels) in 2002 to that in 2004?
Provide a short and direct response. 0.72. What is the ratio of the Aid flow (current US$) in Morocco in 2002 to that in 2004?
Your response must be concise. 0.2. What is the ratio of the Aid flow (current US$) of Sierra Leone in 2002 to that in 2004?
Keep it short and to the point. 2.04. What is the ratio of the Aid flow (current US$) in Yemen, Rep. in 2002 to that in 2004?
Provide a succinct answer. 0.81. What is the ratio of the Aid flow (current US$) in Sub-Saharan Africa (all income levels) in 2003 to that in 2004?
Offer a very short reply. 0.92. What is the ratio of the Aid flow (current US$) in Morocco in 2003 to that in 2004?
Your response must be concise. 0.43. What is the ratio of the Aid flow (current US$) of Yemen, Rep. in 2003 to that in 2004?
Offer a very short reply. 0.72. What is the difference between the highest and the second highest Aid flow (current US$) of Sub-Saharan Africa (all income levels)?
Make the answer very short. 4.72e+07. What is the difference between the highest and the second highest Aid flow (current US$) of Morocco?
Your answer should be very brief. 4.70e+05. What is the difference between the highest and the second highest Aid flow (current US$) of Sierra Leone?
Give a very brief answer. 1.24e+06. What is the difference between the highest and the second highest Aid flow (current US$) in Yemen, Rep.?
Your answer should be very brief. 1.82e+06. What is the difference between the highest and the lowest Aid flow (current US$) of Sub-Saharan Africa (all income levels)?
Provide a succinct answer. 3.02e+08. What is the difference between the highest and the lowest Aid flow (current US$) in Morocco?
Offer a very short reply. 7.90e+05. What is the difference between the highest and the lowest Aid flow (current US$) in Sierra Leone?
Keep it short and to the point. 5.40e+06. What is the difference between the highest and the lowest Aid flow (current US$) of Yemen, Rep.?
Ensure brevity in your answer.  2.20e+06. 